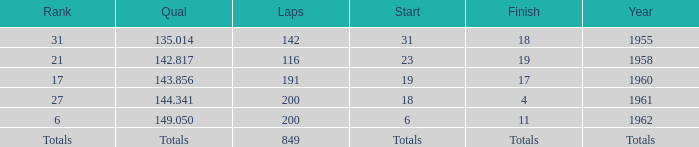What year has a finish of 19? 1958.0. 